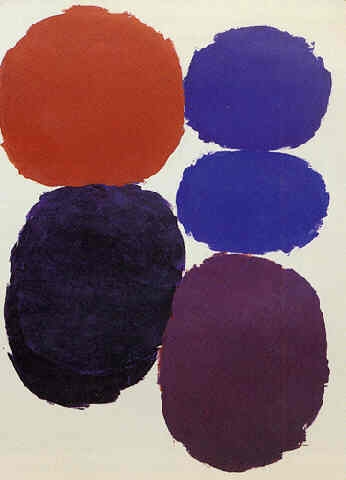What might be the symbolic meaning behind the vertical arrangement of the circles? The vertical arrangement of the circles might symbolize a range of concepts, depending on the viewer's interpretation. One possibility is that it represents growth or ascension, moving from the solid grounding of red through increasingly serene blues to an energizing peak of orange. Alternatively, it could reflect a hierarchy of elements or ideas, each color and its placement contributing a distinct layer to the overall message of the artwork. 